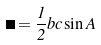<formula> <loc_0><loc_0><loc_500><loc_500>\Delta = \frac { 1 } { 2 } b c \sin A</formula> 